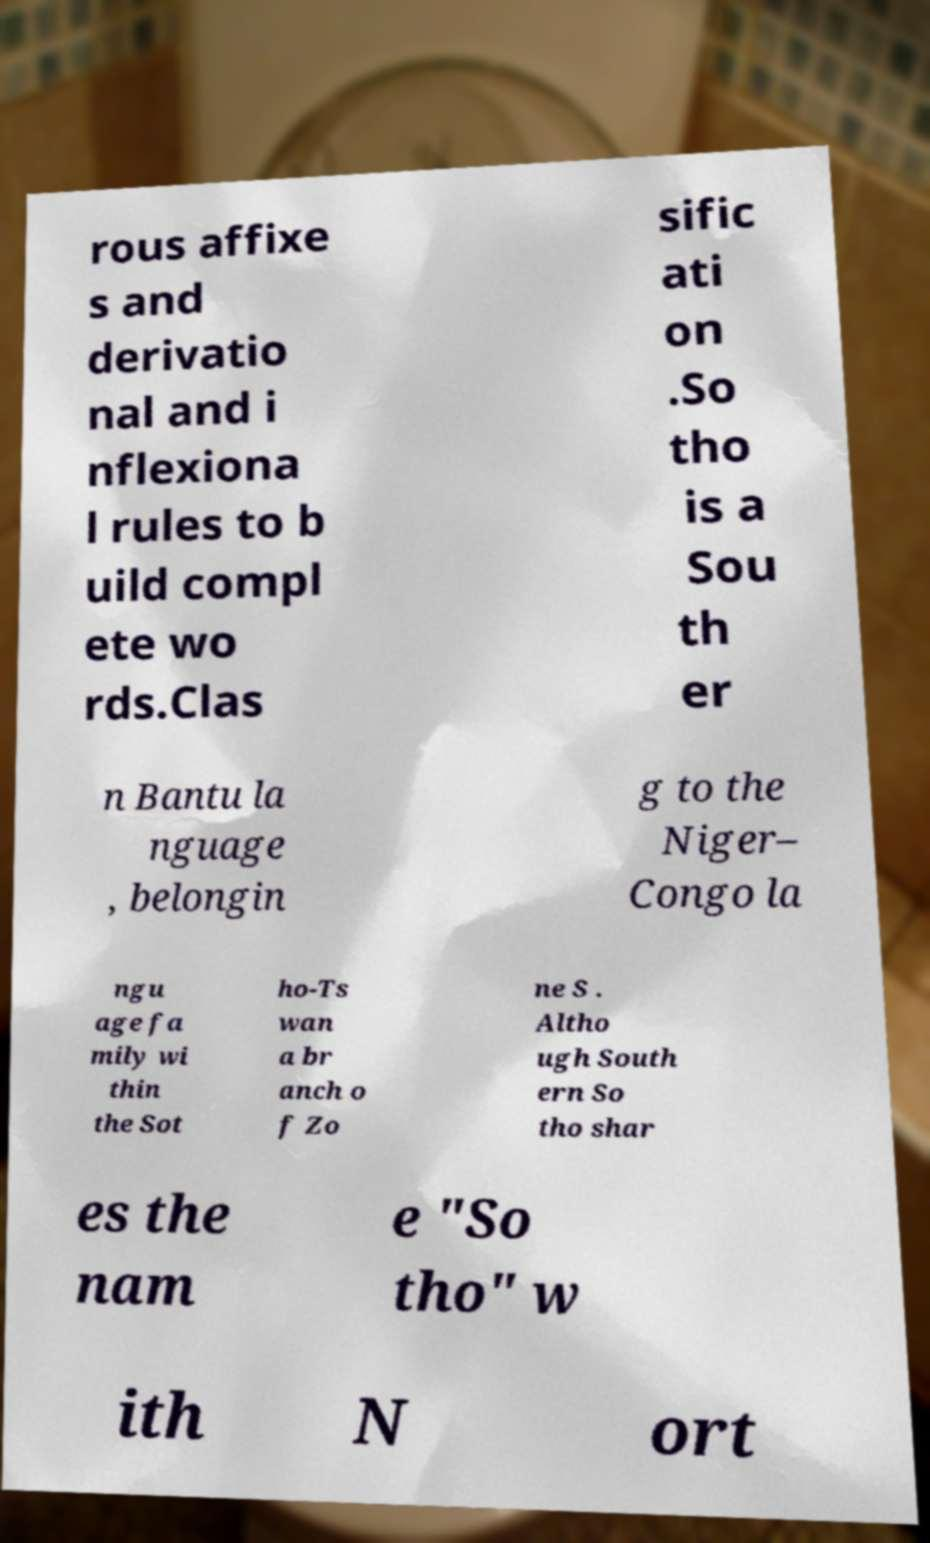Can you read and provide the text displayed in the image?This photo seems to have some interesting text. Can you extract and type it out for me? rous affixe s and derivatio nal and i nflexiona l rules to b uild compl ete wo rds.Clas sific ati on .So tho is a Sou th er n Bantu la nguage , belongin g to the Niger– Congo la ngu age fa mily wi thin the Sot ho-Ts wan a br anch o f Zo ne S . Altho ugh South ern So tho shar es the nam e "So tho" w ith N ort 